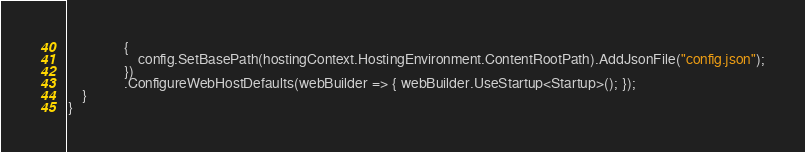Convert code to text. <code><loc_0><loc_0><loc_500><loc_500><_C#_>                {
                    config.SetBasePath(hostingContext.HostingEnvironment.ContentRootPath).AddJsonFile("config.json");
                })
                .ConfigureWebHostDefaults(webBuilder => { webBuilder.UseStartup<Startup>(); });
    }
}</code> 